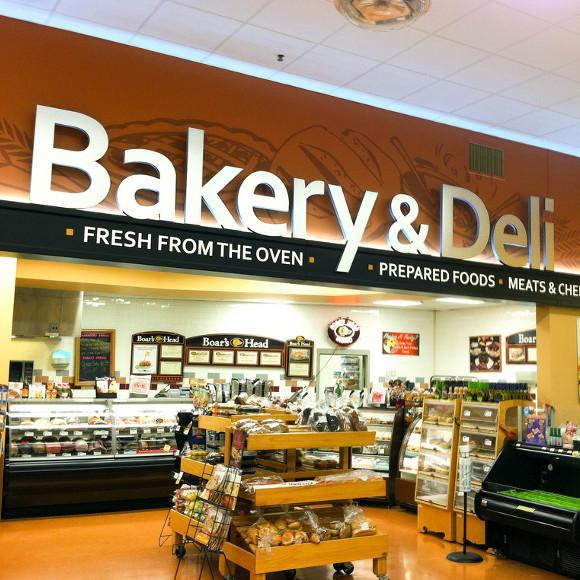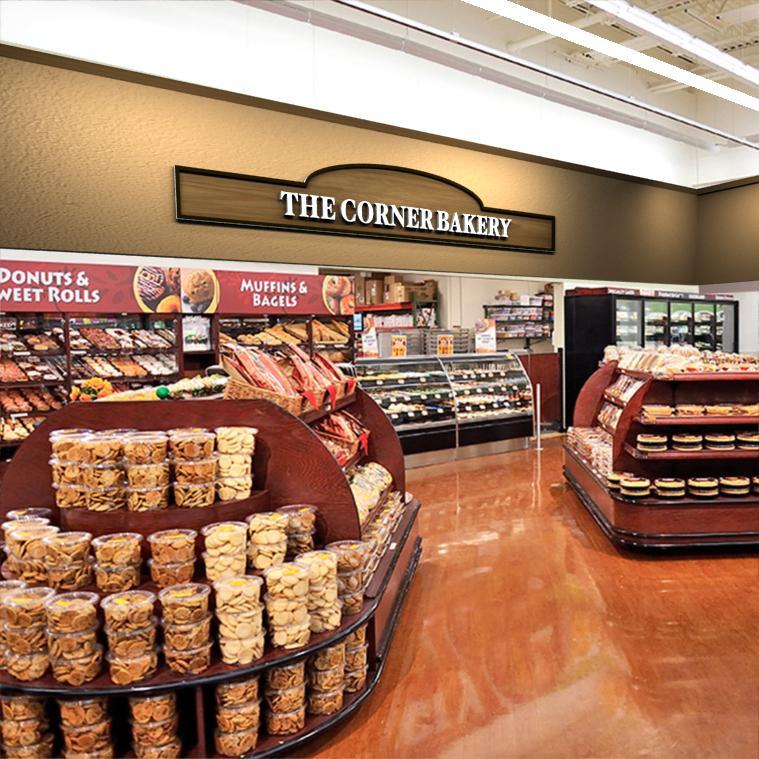The first image is the image on the left, the second image is the image on the right. Examine the images to the left and right. Is the description "In the store there are labels to show a combine bakery and deli." accurate? Answer yes or no. Yes. The first image is the image on the left, the second image is the image on the right. Examine the images to the left and right. Is the description "The bakery sign is in a frame with a rounded top." accurate? Answer yes or no. Yes. 